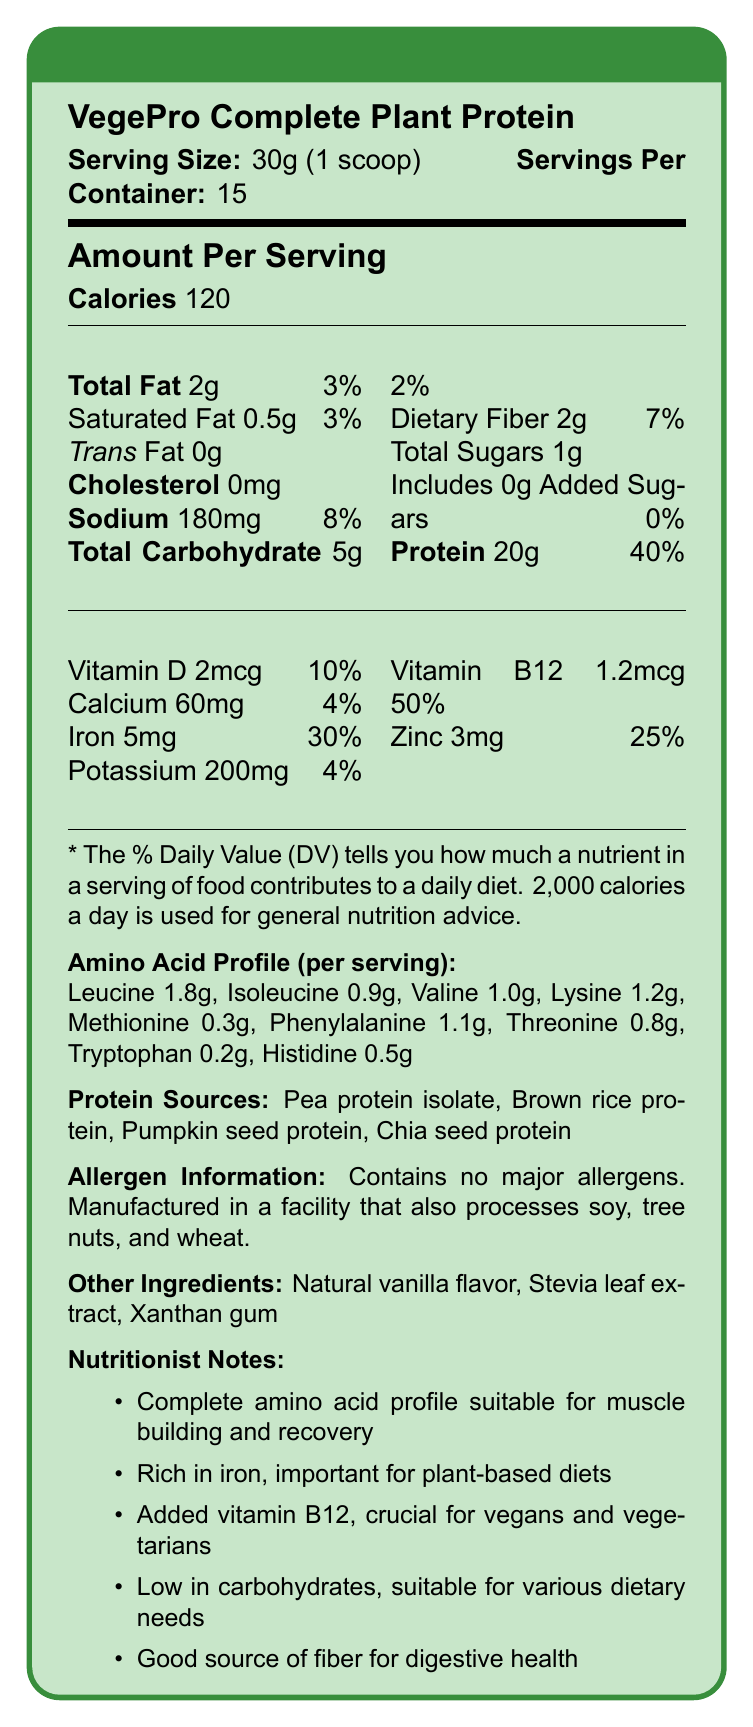what is the serving size for VegePro Complete Plant Protein? The Nutrition Facts Label specifies that the serving size is 30g, equivalent to 1 scoop.
Answer: 30g (1 scoop) how many calories are there per serving? The document clearly states that each serving contains 120 calories.
Answer: 120 what is the percentage of Daily Value for protein per serving? The label indicates that one serving provides 20g of protein, which is 40% of the Daily Value.
Answer: 40% what are the protein sources listed? The "Protein Sources" section in the document lists these sources.
Answer: Pea protein isolate, Brown rice protein, Pumpkin seed protein, Chia seed protein how much iron is in one serving, and what is its daily value percentage? According to the label, one serving contains 5mg of iron, accounting for 30% of the Daily Value.
Answer: 5mg, 30% what is the amount of sodium per serving? The Nutrition Facts Label shows that each serving has 180mg of sodium.
Answer: 180mg does this product contain any major allergens? The allergen information section states that the product contains no major allergens but is manufactured in a facility that processes soy, tree nuts, and wheat.
Answer: No which of the following vitamins is present and has the highest Daily Value percentage? A. Vitamin D B. Calcium C. Vitamin B12 Vitamin B12 has a daily value of 50%, which is higher than that for Vitamin D (10%) and Calcium (4%).
Answer: C. Vitamin B12 which of these amino acids has the lowest content per serving? I. Methionine II. Lysine III. Tryptophan The amino acid profile indicates that Tryptophan has the lowest content at 0.2g per serving.
Answer: III. Tryptophan is the product suitable for low-carb diets? The product contains only 5g of total carbohydrates per serving, making it suitable for low-carb diets.
Answer: Yes summarize the main idea of the document. The document provides an overview of the nutritional composition and benefits of VegePro Complete Plant Protein, aimed at helping consumers make informed dietary choices.
Answer: The document presents the Nutrition Facts Label for VegePro Complete Plant Protein, detailing its serving size, calorie count, macronutrient breakdown, vitamin and mineral content, amino acid profile, protein sources, allergen information, additives, and nutritionist notes. It highlights the product's suitability for muscle building, its richness in iron and vitamin B12, low carbohydrate content, and good fiber source. what flavors or sweeteners are used in the product? The document does not provide specific details about the flavors or sweeteners used beyond mentioning "Natural vanilla flavor" and "Stevia leaf extract" as additives.
Answer: Not enough information what is the total fat content per serving and its daily value percentage? The label indicates that each serving has 2g of total fat, accounting for 3% of the Daily Value.
Answer: 2g, 3% how much vitamin B12 is there per serving? According to the document, each serving contains 1.2mcg of vitamin B12.
Answer: 1.2mcg what is a key benefit of the added vitamin B12? The nutritionist notes mention that the added vitamin B12 is crucial for those following vegan and vegetarian diets.
Answer: Crucial for vegans and vegetarians does the product have any added sugars? The label states that there are 0g of added sugars in the product.
Answer: No 